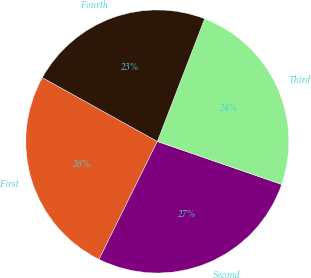Convert chart to OTSL. <chart><loc_0><loc_0><loc_500><loc_500><pie_chart><fcel>First<fcel>Second<fcel>Third<fcel>Fourth<nl><fcel>25.76%<fcel>27.02%<fcel>24.44%<fcel>22.79%<nl></chart> 